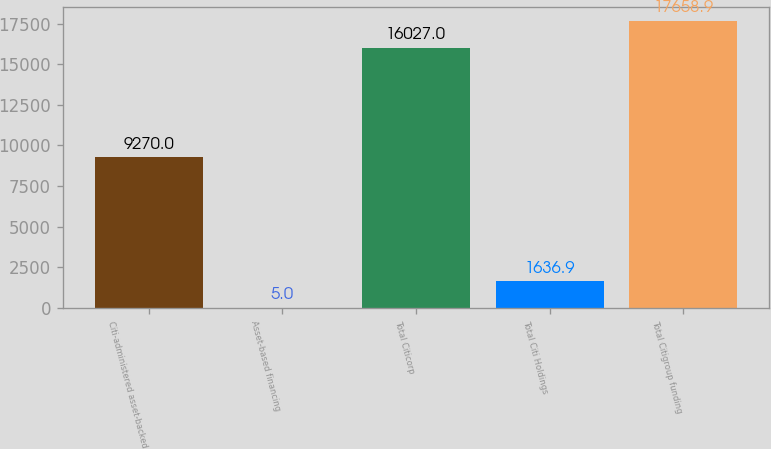Convert chart. <chart><loc_0><loc_0><loc_500><loc_500><bar_chart><fcel>Citi-administered asset-backed<fcel>Asset-based financing<fcel>Total Citicorp<fcel>Total Citi Holdings<fcel>Total Citigroup funding<nl><fcel>9270<fcel>5<fcel>16027<fcel>1636.9<fcel>17658.9<nl></chart> 